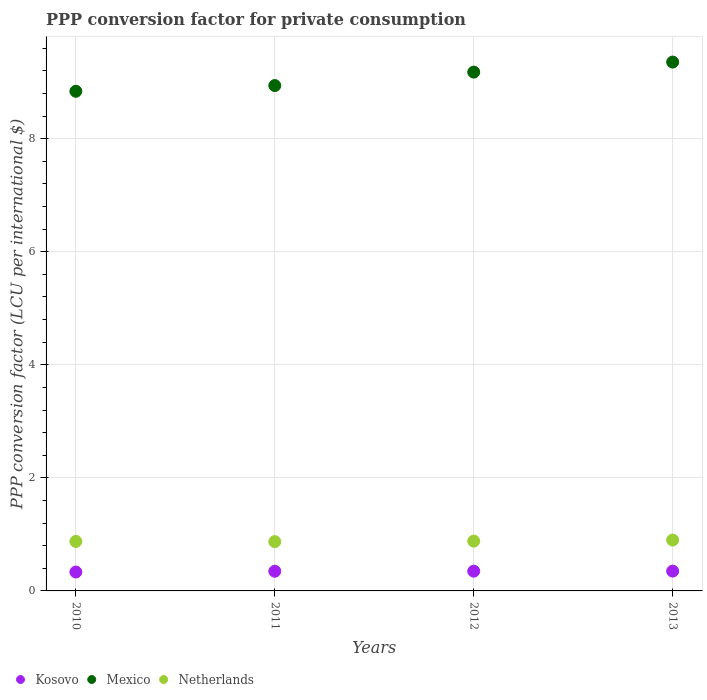What is the PPP conversion factor for private consumption in Mexico in 2013?
Ensure brevity in your answer.  9.36. Across all years, what is the maximum PPP conversion factor for private consumption in Mexico?
Provide a succinct answer. 9.36. Across all years, what is the minimum PPP conversion factor for private consumption in Kosovo?
Keep it short and to the point. 0.33. What is the total PPP conversion factor for private consumption in Mexico in the graph?
Keep it short and to the point. 36.31. What is the difference between the PPP conversion factor for private consumption in Mexico in 2012 and that in 2013?
Keep it short and to the point. -0.18. What is the difference between the PPP conversion factor for private consumption in Netherlands in 2010 and the PPP conversion factor for private consumption in Mexico in 2012?
Ensure brevity in your answer.  -8.3. What is the average PPP conversion factor for private consumption in Netherlands per year?
Provide a succinct answer. 0.88. In the year 2011, what is the difference between the PPP conversion factor for private consumption in Kosovo and PPP conversion factor for private consumption in Netherlands?
Your response must be concise. -0.52. In how many years, is the PPP conversion factor for private consumption in Netherlands greater than 6.4 LCU?
Keep it short and to the point. 0. What is the ratio of the PPP conversion factor for private consumption in Netherlands in 2010 to that in 2013?
Your response must be concise. 0.97. Is the difference between the PPP conversion factor for private consumption in Kosovo in 2011 and 2013 greater than the difference between the PPP conversion factor for private consumption in Netherlands in 2011 and 2013?
Your response must be concise. Yes. What is the difference between the highest and the second highest PPP conversion factor for private consumption in Mexico?
Provide a short and direct response. 0.18. What is the difference between the highest and the lowest PPP conversion factor for private consumption in Kosovo?
Keep it short and to the point. 0.02. Is the sum of the PPP conversion factor for private consumption in Mexico in 2010 and 2011 greater than the maximum PPP conversion factor for private consumption in Kosovo across all years?
Your answer should be very brief. Yes. Is the PPP conversion factor for private consumption in Mexico strictly greater than the PPP conversion factor for private consumption in Kosovo over the years?
Make the answer very short. Yes. Is the PPP conversion factor for private consumption in Mexico strictly less than the PPP conversion factor for private consumption in Kosovo over the years?
Offer a terse response. No. How many dotlines are there?
Give a very brief answer. 3. Are the values on the major ticks of Y-axis written in scientific E-notation?
Offer a very short reply. No. Where does the legend appear in the graph?
Provide a short and direct response. Bottom left. How are the legend labels stacked?
Your answer should be very brief. Horizontal. What is the title of the graph?
Ensure brevity in your answer.  PPP conversion factor for private consumption. Does "Nepal" appear as one of the legend labels in the graph?
Your answer should be compact. No. What is the label or title of the Y-axis?
Offer a very short reply. PPP conversion factor (LCU per international $). What is the PPP conversion factor (LCU per international $) of Kosovo in 2010?
Provide a succinct answer. 0.33. What is the PPP conversion factor (LCU per international $) in Mexico in 2010?
Offer a very short reply. 8.84. What is the PPP conversion factor (LCU per international $) in Netherlands in 2010?
Your answer should be very brief. 0.88. What is the PPP conversion factor (LCU per international $) of Kosovo in 2011?
Provide a short and direct response. 0.35. What is the PPP conversion factor (LCU per international $) in Mexico in 2011?
Give a very brief answer. 8.94. What is the PPP conversion factor (LCU per international $) of Netherlands in 2011?
Your answer should be compact. 0.87. What is the PPP conversion factor (LCU per international $) in Kosovo in 2012?
Offer a terse response. 0.35. What is the PPP conversion factor (LCU per international $) of Mexico in 2012?
Provide a succinct answer. 9.18. What is the PPP conversion factor (LCU per international $) in Netherlands in 2012?
Make the answer very short. 0.88. What is the PPP conversion factor (LCU per international $) in Kosovo in 2013?
Your answer should be compact. 0.35. What is the PPP conversion factor (LCU per international $) in Mexico in 2013?
Give a very brief answer. 9.36. What is the PPP conversion factor (LCU per international $) in Netherlands in 2013?
Your answer should be very brief. 0.9. Across all years, what is the maximum PPP conversion factor (LCU per international $) of Kosovo?
Offer a very short reply. 0.35. Across all years, what is the maximum PPP conversion factor (LCU per international $) of Mexico?
Offer a terse response. 9.36. Across all years, what is the maximum PPP conversion factor (LCU per international $) in Netherlands?
Make the answer very short. 0.9. Across all years, what is the minimum PPP conversion factor (LCU per international $) of Kosovo?
Offer a terse response. 0.33. Across all years, what is the minimum PPP conversion factor (LCU per international $) in Mexico?
Your response must be concise. 8.84. Across all years, what is the minimum PPP conversion factor (LCU per international $) in Netherlands?
Keep it short and to the point. 0.87. What is the total PPP conversion factor (LCU per international $) of Kosovo in the graph?
Your answer should be compact. 1.38. What is the total PPP conversion factor (LCU per international $) of Mexico in the graph?
Provide a succinct answer. 36.31. What is the total PPP conversion factor (LCU per international $) in Netherlands in the graph?
Your answer should be very brief. 3.53. What is the difference between the PPP conversion factor (LCU per international $) of Kosovo in 2010 and that in 2011?
Keep it short and to the point. -0.01. What is the difference between the PPP conversion factor (LCU per international $) of Mexico in 2010 and that in 2011?
Your answer should be compact. -0.1. What is the difference between the PPP conversion factor (LCU per international $) in Netherlands in 2010 and that in 2011?
Your answer should be very brief. 0. What is the difference between the PPP conversion factor (LCU per international $) in Kosovo in 2010 and that in 2012?
Offer a very short reply. -0.01. What is the difference between the PPP conversion factor (LCU per international $) in Mexico in 2010 and that in 2012?
Your answer should be very brief. -0.34. What is the difference between the PPP conversion factor (LCU per international $) in Netherlands in 2010 and that in 2012?
Your answer should be very brief. -0.01. What is the difference between the PPP conversion factor (LCU per international $) of Kosovo in 2010 and that in 2013?
Keep it short and to the point. -0.02. What is the difference between the PPP conversion factor (LCU per international $) of Mexico in 2010 and that in 2013?
Offer a very short reply. -0.52. What is the difference between the PPP conversion factor (LCU per international $) in Netherlands in 2010 and that in 2013?
Give a very brief answer. -0.02. What is the difference between the PPP conversion factor (LCU per international $) in Kosovo in 2011 and that in 2012?
Offer a terse response. -0. What is the difference between the PPP conversion factor (LCU per international $) of Mexico in 2011 and that in 2012?
Offer a terse response. -0.24. What is the difference between the PPP conversion factor (LCU per international $) in Netherlands in 2011 and that in 2012?
Provide a succinct answer. -0.01. What is the difference between the PPP conversion factor (LCU per international $) of Kosovo in 2011 and that in 2013?
Your response must be concise. -0. What is the difference between the PPP conversion factor (LCU per international $) in Mexico in 2011 and that in 2013?
Your response must be concise. -0.42. What is the difference between the PPP conversion factor (LCU per international $) of Netherlands in 2011 and that in 2013?
Provide a short and direct response. -0.03. What is the difference between the PPP conversion factor (LCU per international $) in Kosovo in 2012 and that in 2013?
Provide a succinct answer. -0. What is the difference between the PPP conversion factor (LCU per international $) of Mexico in 2012 and that in 2013?
Your answer should be compact. -0.18. What is the difference between the PPP conversion factor (LCU per international $) of Netherlands in 2012 and that in 2013?
Keep it short and to the point. -0.02. What is the difference between the PPP conversion factor (LCU per international $) in Kosovo in 2010 and the PPP conversion factor (LCU per international $) in Mexico in 2011?
Your answer should be very brief. -8.61. What is the difference between the PPP conversion factor (LCU per international $) of Kosovo in 2010 and the PPP conversion factor (LCU per international $) of Netherlands in 2011?
Keep it short and to the point. -0.54. What is the difference between the PPP conversion factor (LCU per international $) in Mexico in 2010 and the PPP conversion factor (LCU per international $) in Netherlands in 2011?
Provide a succinct answer. 7.97. What is the difference between the PPP conversion factor (LCU per international $) in Kosovo in 2010 and the PPP conversion factor (LCU per international $) in Mexico in 2012?
Provide a succinct answer. -8.84. What is the difference between the PPP conversion factor (LCU per international $) in Kosovo in 2010 and the PPP conversion factor (LCU per international $) in Netherlands in 2012?
Give a very brief answer. -0.55. What is the difference between the PPP conversion factor (LCU per international $) in Mexico in 2010 and the PPP conversion factor (LCU per international $) in Netherlands in 2012?
Your response must be concise. 7.96. What is the difference between the PPP conversion factor (LCU per international $) of Kosovo in 2010 and the PPP conversion factor (LCU per international $) of Mexico in 2013?
Provide a succinct answer. -9.02. What is the difference between the PPP conversion factor (LCU per international $) in Kosovo in 2010 and the PPP conversion factor (LCU per international $) in Netherlands in 2013?
Provide a succinct answer. -0.57. What is the difference between the PPP conversion factor (LCU per international $) in Mexico in 2010 and the PPP conversion factor (LCU per international $) in Netherlands in 2013?
Make the answer very short. 7.94. What is the difference between the PPP conversion factor (LCU per international $) of Kosovo in 2011 and the PPP conversion factor (LCU per international $) of Mexico in 2012?
Offer a very short reply. -8.83. What is the difference between the PPP conversion factor (LCU per international $) of Kosovo in 2011 and the PPP conversion factor (LCU per international $) of Netherlands in 2012?
Ensure brevity in your answer.  -0.53. What is the difference between the PPP conversion factor (LCU per international $) of Mexico in 2011 and the PPP conversion factor (LCU per international $) of Netherlands in 2012?
Ensure brevity in your answer.  8.06. What is the difference between the PPP conversion factor (LCU per international $) in Kosovo in 2011 and the PPP conversion factor (LCU per international $) in Mexico in 2013?
Your answer should be very brief. -9.01. What is the difference between the PPP conversion factor (LCU per international $) in Kosovo in 2011 and the PPP conversion factor (LCU per international $) in Netherlands in 2013?
Provide a succinct answer. -0.55. What is the difference between the PPP conversion factor (LCU per international $) of Mexico in 2011 and the PPP conversion factor (LCU per international $) of Netherlands in 2013?
Offer a very short reply. 8.04. What is the difference between the PPP conversion factor (LCU per international $) in Kosovo in 2012 and the PPP conversion factor (LCU per international $) in Mexico in 2013?
Your response must be concise. -9.01. What is the difference between the PPP conversion factor (LCU per international $) of Kosovo in 2012 and the PPP conversion factor (LCU per international $) of Netherlands in 2013?
Ensure brevity in your answer.  -0.55. What is the difference between the PPP conversion factor (LCU per international $) of Mexico in 2012 and the PPP conversion factor (LCU per international $) of Netherlands in 2013?
Give a very brief answer. 8.28. What is the average PPP conversion factor (LCU per international $) in Kosovo per year?
Offer a terse response. 0.35. What is the average PPP conversion factor (LCU per international $) of Mexico per year?
Make the answer very short. 9.08. What is the average PPP conversion factor (LCU per international $) in Netherlands per year?
Ensure brevity in your answer.  0.88. In the year 2010, what is the difference between the PPP conversion factor (LCU per international $) in Kosovo and PPP conversion factor (LCU per international $) in Mexico?
Give a very brief answer. -8.5. In the year 2010, what is the difference between the PPP conversion factor (LCU per international $) of Kosovo and PPP conversion factor (LCU per international $) of Netherlands?
Provide a short and direct response. -0.54. In the year 2010, what is the difference between the PPP conversion factor (LCU per international $) in Mexico and PPP conversion factor (LCU per international $) in Netherlands?
Provide a short and direct response. 7.96. In the year 2011, what is the difference between the PPP conversion factor (LCU per international $) of Kosovo and PPP conversion factor (LCU per international $) of Mexico?
Ensure brevity in your answer.  -8.59. In the year 2011, what is the difference between the PPP conversion factor (LCU per international $) in Kosovo and PPP conversion factor (LCU per international $) in Netherlands?
Your answer should be compact. -0.52. In the year 2011, what is the difference between the PPP conversion factor (LCU per international $) in Mexico and PPP conversion factor (LCU per international $) in Netherlands?
Offer a very short reply. 8.07. In the year 2012, what is the difference between the PPP conversion factor (LCU per international $) of Kosovo and PPP conversion factor (LCU per international $) of Mexico?
Make the answer very short. -8.83. In the year 2012, what is the difference between the PPP conversion factor (LCU per international $) of Kosovo and PPP conversion factor (LCU per international $) of Netherlands?
Offer a very short reply. -0.53. In the year 2012, what is the difference between the PPP conversion factor (LCU per international $) of Mexico and PPP conversion factor (LCU per international $) of Netherlands?
Keep it short and to the point. 8.3. In the year 2013, what is the difference between the PPP conversion factor (LCU per international $) of Kosovo and PPP conversion factor (LCU per international $) of Mexico?
Your answer should be very brief. -9.01. In the year 2013, what is the difference between the PPP conversion factor (LCU per international $) of Kosovo and PPP conversion factor (LCU per international $) of Netherlands?
Your answer should be very brief. -0.55. In the year 2013, what is the difference between the PPP conversion factor (LCU per international $) of Mexico and PPP conversion factor (LCU per international $) of Netherlands?
Your answer should be compact. 8.46. What is the ratio of the PPP conversion factor (LCU per international $) of Kosovo in 2010 to that in 2011?
Make the answer very short. 0.96. What is the ratio of the PPP conversion factor (LCU per international $) of Mexico in 2010 to that in 2011?
Give a very brief answer. 0.99. What is the ratio of the PPP conversion factor (LCU per international $) in Netherlands in 2010 to that in 2011?
Make the answer very short. 1. What is the ratio of the PPP conversion factor (LCU per international $) in Kosovo in 2010 to that in 2012?
Ensure brevity in your answer.  0.96. What is the ratio of the PPP conversion factor (LCU per international $) in Netherlands in 2010 to that in 2012?
Provide a succinct answer. 0.99. What is the ratio of the PPP conversion factor (LCU per international $) of Kosovo in 2010 to that in 2013?
Provide a succinct answer. 0.95. What is the ratio of the PPP conversion factor (LCU per international $) of Mexico in 2010 to that in 2013?
Your answer should be very brief. 0.94. What is the ratio of the PPP conversion factor (LCU per international $) of Netherlands in 2010 to that in 2013?
Your response must be concise. 0.97. What is the ratio of the PPP conversion factor (LCU per international $) of Kosovo in 2011 to that in 2012?
Your answer should be very brief. 1. What is the ratio of the PPP conversion factor (LCU per international $) in Mexico in 2011 to that in 2012?
Provide a succinct answer. 0.97. What is the ratio of the PPP conversion factor (LCU per international $) in Netherlands in 2011 to that in 2012?
Provide a short and direct response. 0.99. What is the ratio of the PPP conversion factor (LCU per international $) in Kosovo in 2011 to that in 2013?
Provide a succinct answer. 0.99. What is the ratio of the PPP conversion factor (LCU per international $) of Mexico in 2011 to that in 2013?
Your answer should be very brief. 0.96. What is the ratio of the PPP conversion factor (LCU per international $) in Netherlands in 2011 to that in 2013?
Make the answer very short. 0.97. What is the ratio of the PPP conversion factor (LCU per international $) of Kosovo in 2012 to that in 2013?
Make the answer very short. 1. What is the ratio of the PPP conversion factor (LCU per international $) in Netherlands in 2012 to that in 2013?
Offer a very short reply. 0.98. What is the difference between the highest and the second highest PPP conversion factor (LCU per international $) of Mexico?
Offer a terse response. 0.18. What is the difference between the highest and the second highest PPP conversion factor (LCU per international $) in Netherlands?
Your response must be concise. 0.02. What is the difference between the highest and the lowest PPP conversion factor (LCU per international $) of Kosovo?
Make the answer very short. 0.02. What is the difference between the highest and the lowest PPP conversion factor (LCU per international $) in Mexico?
Ensure brevity in your answer.  0.52. What is the difference between the highest and the lowest PPP conversion factor (LCU per international $) in Netherlands?
Provide a short and direct response. 0.03. 